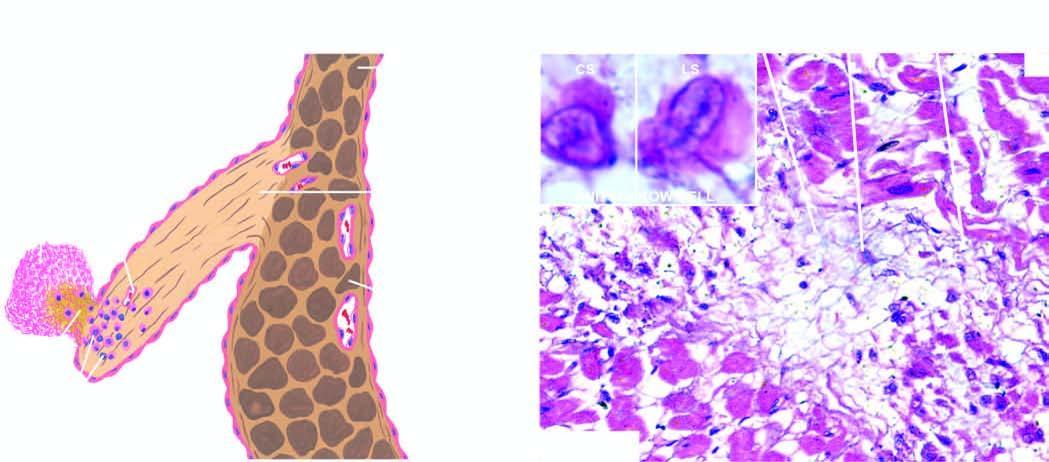does etastatic carcinomatous deposits in the show healed aschoff nodules in the interstitium having collagen, sparse cellula rity, a multinucleate giant cell and anitschkow cells?
Answer the question using a single word or phrase. No 